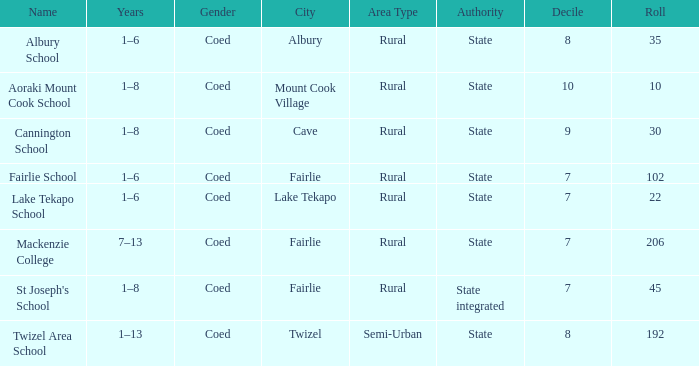What is the total Decile that has a state authority, fairlie area and roll smarter than 206? 1.0. 